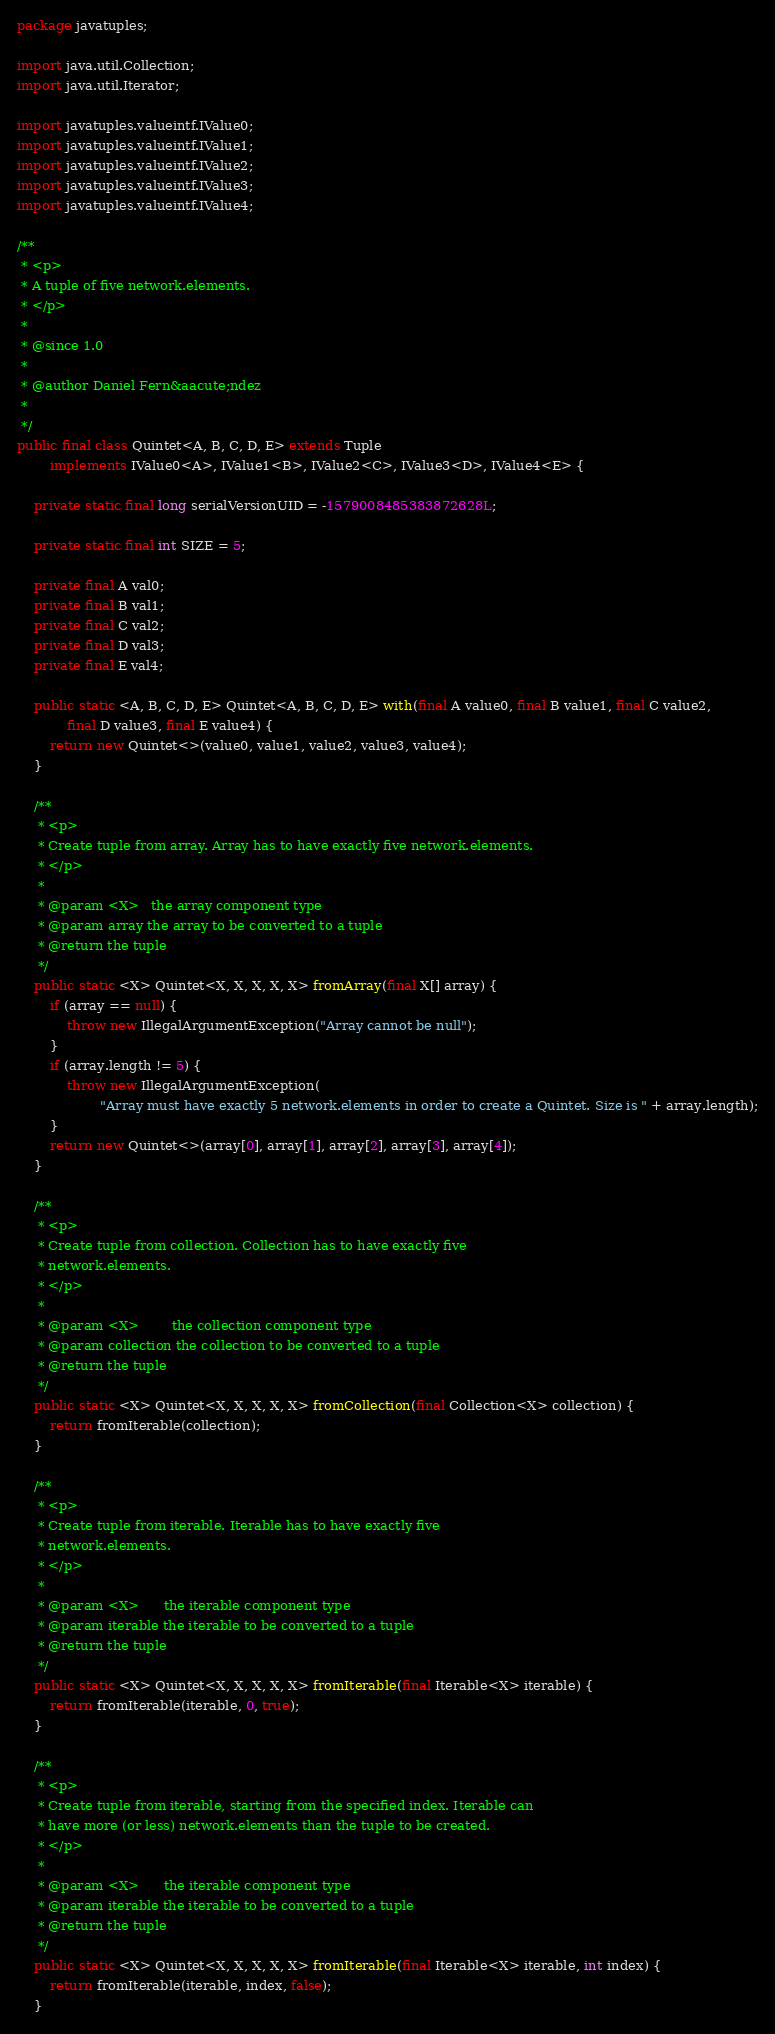<code> <loc_0><loc_0><loc_500><loc_500><_Java_>package javatuples;

import java.util.Collection;
import java.util.Iterator;

import javatuples.valueintf.IValue0;
import javatuples.valueintf.IValue1;
import javatuples.valueintf.IValue2;
import javatuples.valueintf.IValue3;
import javatuples.valueintf.IValue4;

/**
 * <p>
 * A tuple of five network.elements.
 * </p>
 * 
 * @since 1.0
 * 
 * @author Daniel Fern&aacute;ndez
 *
 */
public final class Quintet<A, B, C, D, E> extends Tuple
		implements IValue0<A>, IValue1<B>, IValue2<C>, IValue3<D>, IValue4<E> {

	private static final long serialVersionUID = -1579008485383872628L;

	private static final int SIZE = 5;

	private final A val0;
	private final B val1;
	private final C val2;
	private final D val3;
	private final E val4;

	public static <A, B, C, D, E> Quintet<A, B, C, D, E> with(final A value0, final B value1, final C value2,
			final D value3, final E value4) {
		return new Quintet<>(value0, value1, value2, value3, value4);
	}

	/**
	 * <p>
	 * Create tuple from array. Array has to have exactly five network.elements.
	 * </p>
	 * 
	 * @param <X>   the array component type
	 * @param array the array to be converted to a tuple
	 * @return the tuple
	 */
	public static <X> Quintet<X, X, X, X, X> fromArray(final X[] array) {
		if (array == null) {
			throw new IllegalArgumentException("Array cannot be null");
		}
		if (array.length != 5) {
			throw new IllegalArgumentException(
					"Array must have exactly 5 network.elements in order to create a Quintet. Size is " + array.length);
		}
		return new Quintet<>(array[0], array[1], array[2], array[3], array[4]);
	}

	/**
	 * <p>
	 * Create tuple from collection. Collection has to have exactly five
	 * network.elements.
	 * </p>
	 * 
	 * @param <X>        the collection component type
	 * @param collection the collection to be converted to a tuple
	 * @return the tuple
	 */
	public static <X> Quintet<X, X, X, X, X> fromCollection(final Collection<X> collection) {
		return fromIterable(collection);
	}

	/**
	 * <p>
	 * Create tuple from iterable. Iterable has to have exactly five
	 * network.elements.
	 * </p>
	 * 
	 * @param <X>      the iterable component type
	 * @param iterable the iterable to be converted to a tuple
	 * @return the tuple
	 */
	public static <X> Quintet<X, X, X, X, X> fromIterable(final Iterable<X> iterable) {
		return fromIterable(iterable, 0, true);
	}

	/**
	 * <p>
	 * Create tuple from iterable, starting from the specified index. Iterable can
	 * have more (or less) network.elements than the tuple to be created.
	 * </p>
	 * 
	 * @param <X>      the iterable component type
	 * @param iterable the iterable to be converted to a tuple
	 * @return the tuple
	 */
	public static <X> Quintet<X, X, X, X, X> fromIterable(final Iterable<X> iterable, int index) {
		return fromIterable(iterable, index, false);
	}
</code> 